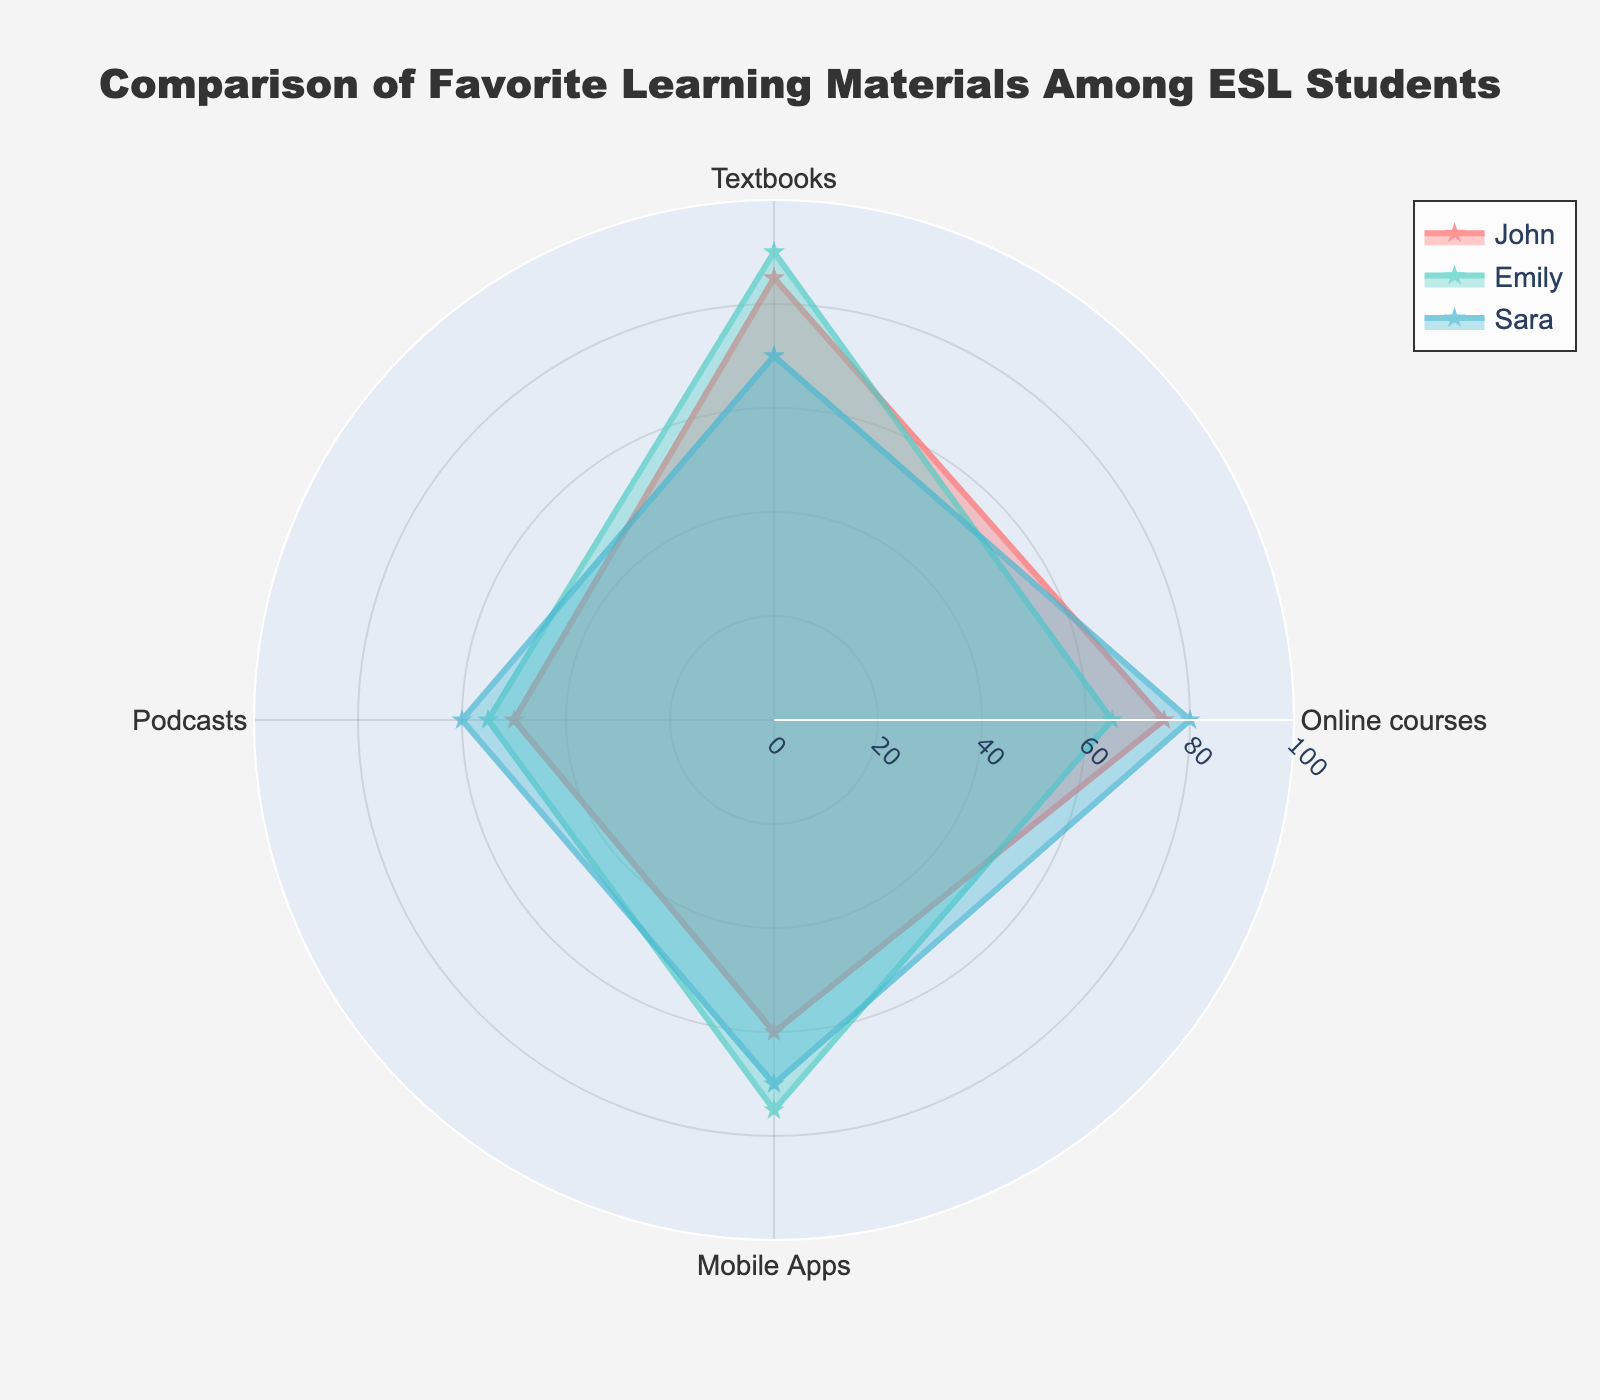How many learning materials are compared in the radar chart? Count the number of distinct categories listed around the radar chart.
Answer: 4 Which student has the highest preference for textbooks? Look at the point labeled 'Textbooks' for each student and identify the one with the highest value.
Answer: Emily What is the difference in preference for mobile apps between John and Emily? Subtract John's value for mobile apps from Emily's value for mobile apps, which is 75 - 60.
Answer: 15 Which learning material do all students rate the lowest? Identify the category with the lowest values for each student by comparing the point in the radar where the four categories are displayed.
Answer: Podcasts What is the average preference for online courses among the three students? Sum the values given for online courses for each student and divide by the number of students: (75 + 65 + 80) / 3.
Answer: 73.33 Do any students have the same preference values for any of the learning materials? Compare the values for each learning material across all students to see if any values are identical.
Answer: No Which student shows the most balanced preference across all learning materials? Identify the student with the smallest range between their highest and lowest values across all categories.
Answer: Sara What is the combined preference for textbooks and podcasts for Sara? Sum Sara's values for textbooks and podcasts: 70 + 60.
Answer: 130 Is there a learning material for which all students have preferences above 70? Look for a category where each student's value is greater than 70 by checking each category around the radar.
Answer: No 